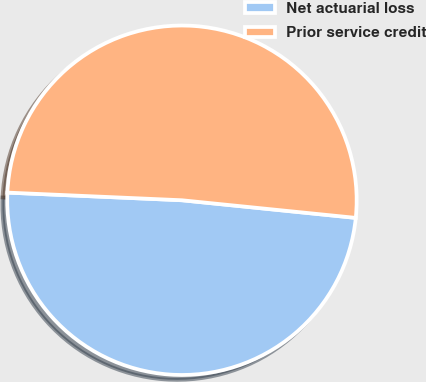Convert chart. <chart><loc_0><loc_0><loc_500><loc_500><pie_chart><fcel>Net actuarial loss<fcel>Prior service credit<nl><fcel>49.09%<fcel>50.91%<nl></chart> 